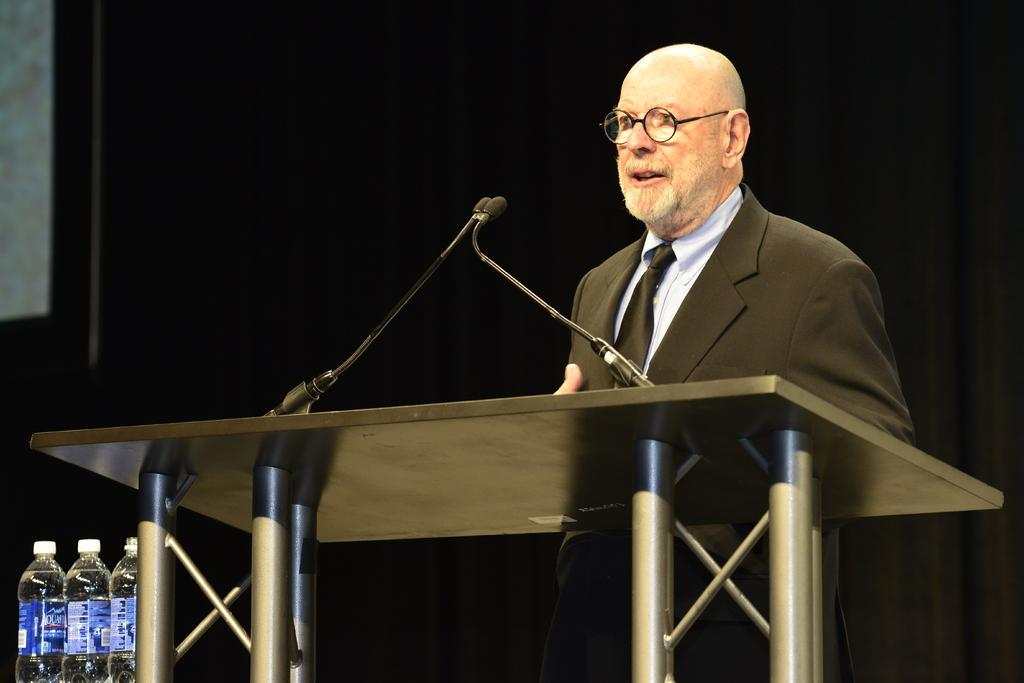Who is the main subject in the image? There is a man in the image. What is the man doing in the image? The man is standing near a podium and speaking. What is the man wearing in the image? The man is wearing a tie, a shirt, a coat, and spectacles. Where are the water bottles located in the image? The water bottles are on the left side of the image. Can you see any ghosts in the image? No, there are no ghosts present in the image. What type of animals can be seen at the zoo in the image? There is no zoo or animals present in the image; it features a man standing near a podium and speaking. 